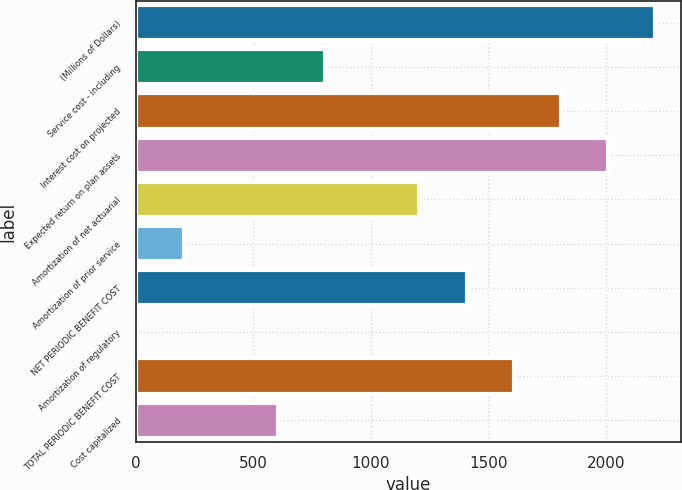Convert chart to OTSL. <chart><loc_0><loc_0><loc_500><loc_500><bar_chart><fcel>(Millions of Dollars)<fcel>Service cost - including<fcel>Interest cost on projected<fcel>Expected return on plan assets<fcel>Amortization of net actuarial<fcel>Amortization of prior service<fcel>NET PERIODIC BENEFIT COST<fcel>Amortization of regulatory<fcel>TOTAL PERIODIC BENEFIT COST<fcel>Cost capitalized<nl><fcel>2210.8<fcel>805.2<fcel>1809.2<fcel>2010<fcel>1206.8<fcel>202.8<fcel>1407.6<fcel>2<fcel>1608.4<fcel>604.4<nl></chart> 